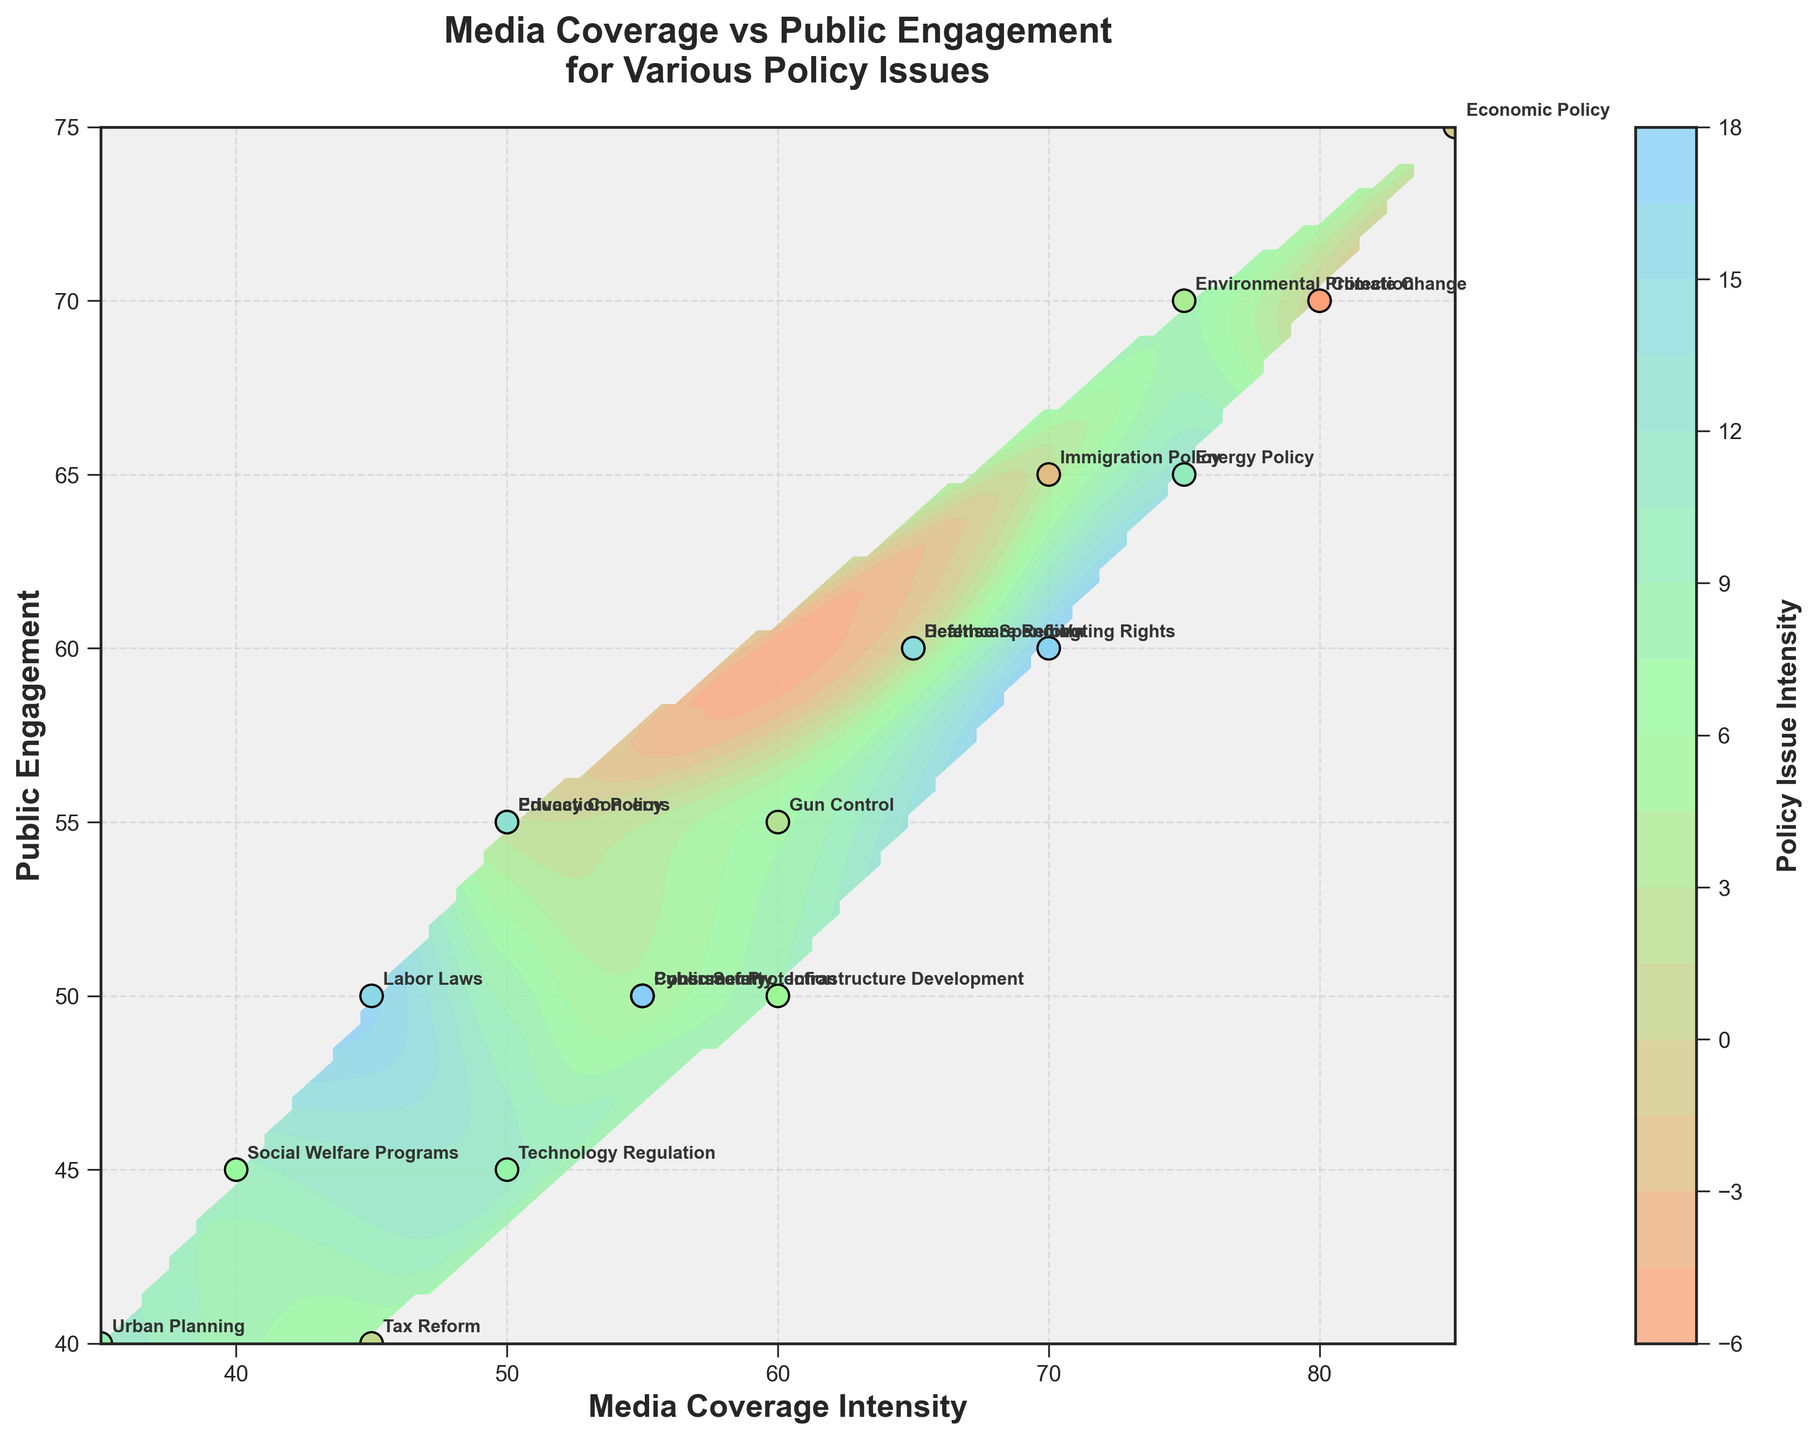What is the title of the figure? The title is typically located at the top of the figure. It summarizes what the figure is about.
Answer: "Media Coverage vs Public Engagement for Various Policy Issues" What are the labels of the x-axis and y-axis? The labels for the x-axis and y-axis are essential descriptors provided along these axes to describe the data represented.
Answer: The x-axis label is "Media Coverage Intensity" and the y-axis label is "Public Engagement" Which policy issue has the highest media coverage intensity? By looking at the horizontal position of the points, the policy issue positioned farthest to the right has the highest media coverage intensity.
Answer: Economic Policy Which policy issue has the lowest public engagement? By looking at the vertical position of the points, the policy issue positioned lowest on the graph has the lowest public engagement.
Answer: Urban Planning How many different policy issues are represented in the figure? The number of policy issues corresponds to the number of annotated points in the figure.
Answer: 20 What is the approximate range of media coverage intensity displayed in the figure? The range can be determined by looking at the minimum and maximum values on the x-axis.
Answer: Approximately 35 to 85 What is the approximate range of public engagement displayed in the figure? The range can be determined by looking at the minimum and maximum values on the y-axis.
Answer: Approximately 40 to 75 Which policy issue has higher public engagement, Healthcare Reform or Cybersecurity? By comparing the vertical positions of the points labeled Healthcare Reform and Cybersecurity, the one that is positioned higher has higher public engagement.
Answer: Healthcare Reform Does Economic Policy have higher or lower public engagement compared to Climate Change? By comparing the vertical positions of the points labeled Economic Policy and Climate Change, we determine which one has a higher value.
Answer: Higher Which policy issues have both media coverage intensity and public engagement above 70? By locating the points in the top-right quadrant (above 70 on both axes), we can identify these policy issues.
Answer: Climate Change and Economic Policy 